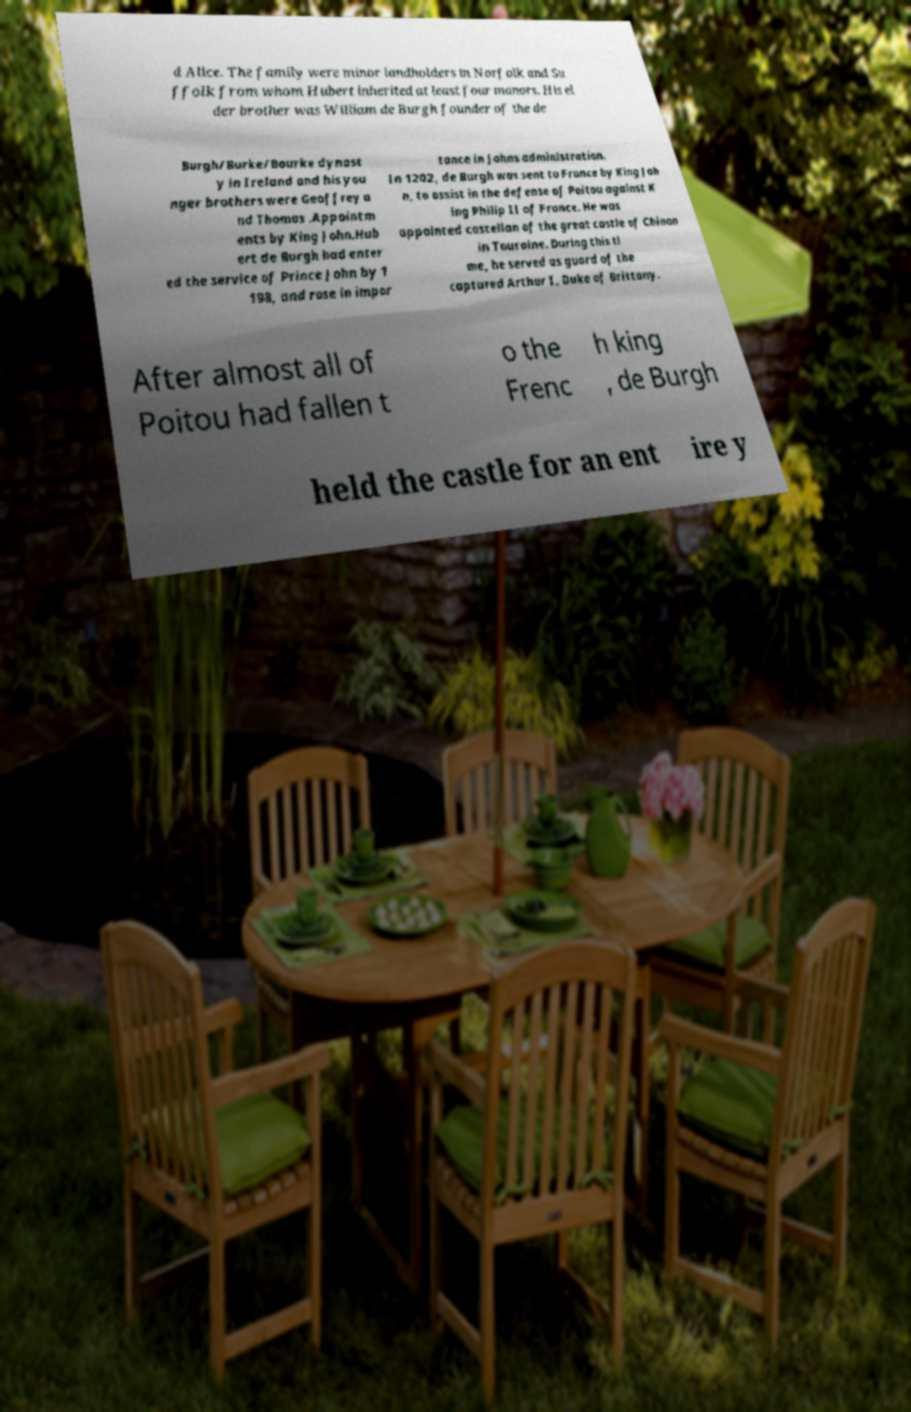There's text embedded in this image that I need extracted. Can you transcribe it verbatim? d Alice. The family were minor landholders in Norfolk and Su ffolk from whom Hubert inherited at least four manors. His el der brother was William de Burgh founder of the de Burgh/Burke/Bourke dynast y in Ireland and his you nger brothers were Geoffrey a nd Thomas .Appointm ents by King John.Hub ert de Burgh had enter ed the service of Prince John by 1 198, and rose in impor tance in Johns administration. In 1202, de Burgh was sent to France by King Joh n, to assist in the defense of Poitou against K ing Philip II of France. He was appointed castellan of the great castle of Chinon in Touraine. During this ti me, he served as guard of the captured Arthur I, Duke of Brittany. After almost all of Poitou had fallen t o the Frenc h king , de Burgh held the castle for an ent ire y 